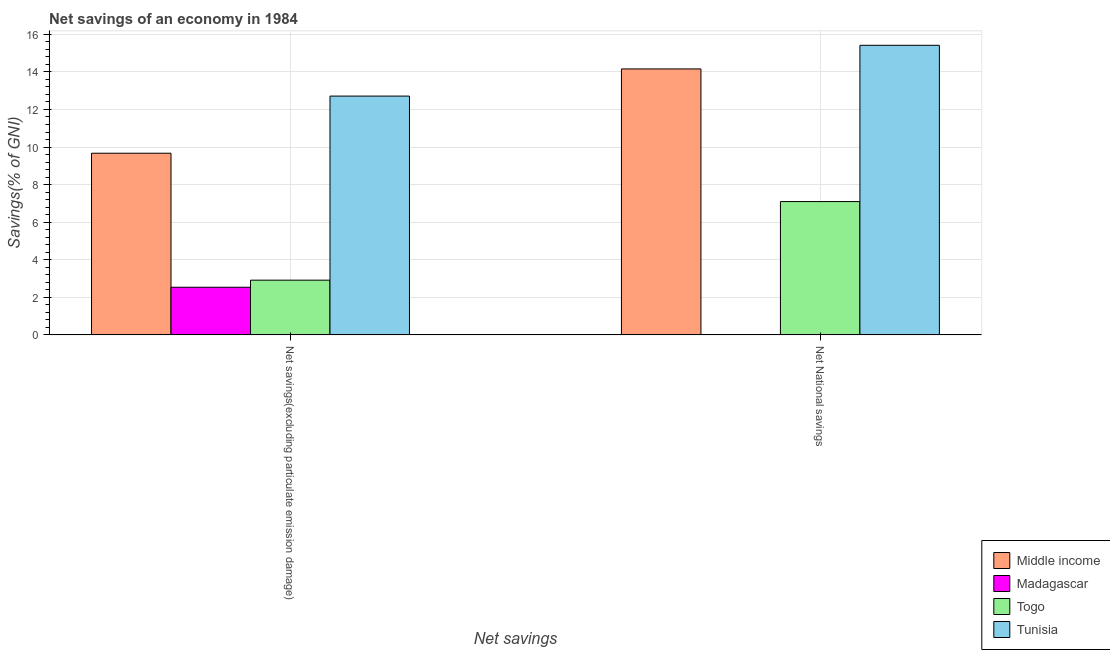How many different coloured bars are there?
Keep it short and to the point. 4. Are the number of bars per tick equal to the number of legend labels?
Your response must be concise. No. Are the number of bars on each tick of the X-axis equal?
Your answer should be compact. No. How many bars are there on the 2nd tick from the right?
Provide a succinct answer. 4. What is the label of the 1st group of bars from the left?
Give a very brief answer. Net savings(excluding particulate emission damage). What is the net savings(excluding particulate emission damage) in Madagascar?
Your answer should be compact. 2.54. Across all countries, what is the maximum net savings(excluding particulate emission damage)?
Provide a succinct answer. 12.71. Across all countries, what is the minimum net savings(excluding particulate emission damage)?
Keep it short and to the point. 2.54. In which country was the net national savings maximum?
Give a very brief answer. Tunisia. What is the total net savings(excluding particulate emission damage) in the graph?
Make the answer very short. 27.83. What is the difference between the net savings(excluding particulate emission damage) in Madagascar and that in Tunisia?
Offer a terse response. -10.18. What is the difference between the net national savings in Togo and the net savings(excluding particulate emission damage) in Madagascar?
Ensure brevity in your answer.  4.56. What is the average net national savings per country?
Keep it short and to the point. 9.17. What is the difference between the net national savings and net savings(excluding particulate emission damage) in Togo?
Ensure brevity in your answer.  4.18. What is the ratio of the net national savings in Tunisia to that in Middle income?
Provide a succinct answer. 1.09. Is the net savings(excluding particulate emission damage) in Togo less than that in Madagascar?
Your response must be concise. No. In how many countries, is the net savings(excluding particulate emission damage) greater than the average net savings(excluding particulate emission damage) taken over all countries?
Provide a succinct answer. 2. Are all the bars in the graph horizontal?
Offer a very short reply. No. How many countries are there in the graph?
Give a very brief answer. 4. Does the graph contain any zero values?
Provide a short and direct response. Yes. How are the legend labels stacked?
Offer a terse response. Vertical. What is the title of the graph?
Ensure brevity in your answer.  Net savings of an economy in 1984. Does "Russian Federation" appear as one of the legend labels in the graph?
Provide a short and direct response. No. What is the label or title of the X-axis?
Your answer should be very brief. Net savings. What is the label or title of the Y-axis?
Provide a succinct answer. Savings(% of GNI). What is the Savings(% of GNI) in Middle income in Net savings(excluding particulate emission damage)?
Your response must be concise. 9.67. What is the Savings(% of GNI) in Madagascar in Net savings(excluding particulate emission damage)?
Ensure brevity in your answer.  2.54. What is the Savings(% of GNI) in Togo in Net savings(excluding particulate emission damage)?
Give a very brief answer. 2.91. What is the Savings(% of GNI) of Tunisia in Net savings(excluding particulate emission damage)?
Make the answer very short. 12.71. What is the Savings(% of GNI) in Middle income in Net National savings?
Your answer should be compact. 14.16. What is the Savings(% of GNI) in Madagascar in Net National savings?
Your answer should be very brief. 0. What is the Savings(% of GNI) in Togo in Net National savings?
Offer a terse response. 7.1. What is the Savings(% of GNI) in Tunisia in Net National savings?
Your response must be concise. 15.42. Across all Net savings, what is the maximum Savings(% of GNI) in Middle income?
Your answer should be very brief. 14.16. Across all Net savings, what is the maximum Savings(% of GNI) of Madagascar?
Provide a succinct answer. 2.54. Across all Net savings, what is the maximum Savings(% of GNI) of Togo?
Offer a very short reply. 7.1. Across all Net savings, what is the maximum Savings(% of GNI) of Tunisia?
Give a very brief answer. 15.42. Across all Net savings, what is the minimum Savings(% of GNI) of Middle income?
Provide a succinct answer. 9.67. Across all Net savings, what is the minimum Savings(% of GNI) of Madagascar?
Give a very brief answer. 0. Across all Net savings, what is the minimum Savings(% of GNI) in Togo?
Ensure brevity in your answer.  2.91. Across all Net savings, what is the minimum Savings(% of GNI) of Tunisia?
Your answer should be compact. 12.71. What is the total Savings(% of GNI) of Middle income in the graph?
Keep it short and to the point. 23.83. What is the total Savings(% of GNI) in Madagascar in the graph?
Provide a succinct answer. 2.54. What is the total Savings(% of GNI) of Togo in the graph?
Offer a very short reply. 10.01. What is the total Savings(% of GNI) of Tunisia in the graph?
Your answer should be very brief. 28.13. What is the difference between the Savings(% of GNI) in Middle income in Net savings(excluding particulate emission damage) and that in Net National savings?
Offer a terse response. -4.49. What is the difference between the Savings(% of GNI) in Togo in Net savings(excluding particulate emission damage) and that in Net National savings?
Provide a short and direct response. -4.18. What is the difference between the Savings(% of GNI) in Tunisia in Net savings(excluding particulate emission damage) and that in Net National savings?
Your answer should be compact. -2.7. What is the difference between the Savings(% of GNI) of Middle income in Net savings(excluding particulate emission damage) and the Savings(% of GNI) of Togo in Net National savings?
Provide a succinct answer. 2.57. What is the difference between the Savings(% of GNI) in Middle income in Net savings(excluding particulate emission damage) and the Savings(% of GNI) in Tunisia in Net National savings?
Your response must be concise. -5.75. What is the difference between the Savings(% of GNI) in Madagascar in Net savings(excluding particulate emission damage) and the Savings(% of GNI) in Togo in Net National savings?
Ensure brevity in your answer.  -4.56. What is the difference between the Savings(% of GNI) in Madagascar in Net savings(excluding particulate emission damage) and the Savings(% of GNI) in Tunisia in Net National savings?
Your response must be concise. -12.88. What is the difference between the Savings(% of GNI) of Togo in Net savings(excluding particulate emission damage) and the Savings(% of GNI) of Tunisia in Net National savings?
Your answer should be compact. -12.5. What is the average Savings(% of GNI) in Middle income per Net savings?
Your answer should be very brief. 11.91. What is the average Savings(% of GNI) in Madagascar per Net savings?
Your response must be concise. 1.27. What is the average Savings(% of GNI) in Togo per Net savings?
Your answer should be very brief. 5.01. What is the average Savings(% of GNI) in Tunisia per Net savings?
Ensure brevity in your answer.  14.06. What is the difference between the Savings(% of GNI) in Middle income and Savings(% of GNI) in Madagascar in Net savings(excluding particulate emission damage)?
Keep it short and to the point. 7.13. What is the difference between the Savings(% of GNI) of Middle income and Savings(% of GNI) of Togo in Net savings(excluding particulate emission damage)?
Make the answer very short. 6.76. What is the difference between the Savings(% of GNI) of Middle income and Savings(% of GNI) of Tunisia in Net savings(excluding particulate emission damage)?
Your answer should be very brief. -3.04. What is the difference between the Savings(% of GNI) of Madagascar and Savings(% of GNI) of Togo in Net savings(excluding particulate emission damage)?
Your answer should be very brief. -0.38. What is the difference between the Savings(% of GNI) in Madagascar and Savings(% of GNI) in Tunisia in Net savings(excluding particulate emission damage)?
Give a very brief answer. -10.18. What is the difference between the Savings(% of GNI) of Togo and Savings(% of GNI) of Tunisia in Net savings(excluding particulate emission damage)?
Your response must be concise. -9.8. What is the difference between the Savings(% of GNI) in Middle income and Savings(% of GNI) in Togo in Net National savings?
Give a very brief answer. 7.06. What is the difference between the Savings(% of GNI) in Middle income and Savings(% of GNI) in Tunisia in Net National savings?
Make the answer very short. -1.26. What is the difference between the Savings(% of GNI) of Togo and Savings(% of GNI) of Tunisia in Net National savings?
Your answer should be compact. -8.32. What is the ratio of the Savings(% of GNI) of Middle income in Net savings(excluding particulate emission damage) to that in Net National savings?
Give a very brief answer. 0.68. What is the ratio of the Savings(% of GNI) in Togo in Net savings(excluding particulate emission damage) to that in Net National savings?
Ensure brevity in your answer.  0.41. What is the ratio of the Savings(% of GNI) in Tunisia in Net savings(excluding particulate emission damage) to that in Net National savings?
Give a very brief answer. 0.82. What is the difference between the highest and the second highest Savings(% of GNI) in Middle income?
Make the answer very short. 4.49. What is the difference between the highest and the second highest Savings(% of GNI) of Togo?
Offer a very short reply. 4.18. What is the difference between the highest and the second highest Savings(% of GNI) of Tunisia?
Make the answer very short. 2.7. What is the difference between the highest and the lowest Savings(% of GNI) in Middle income?
Keep it short and to the point. 4.49. What is the difference between the highest and the lowest Savings(% of GNI) of Madagascar?
Offer a very short reply. 2.54. What is the difference between the highest and the lowest Savings(% of GNI) of Togo?
Ensure brevity in your answer.  4.18. What is the difference between the highest and the lowest Savings(% of GNI) of Tunisia?
Make the answer very short. 2.7. 